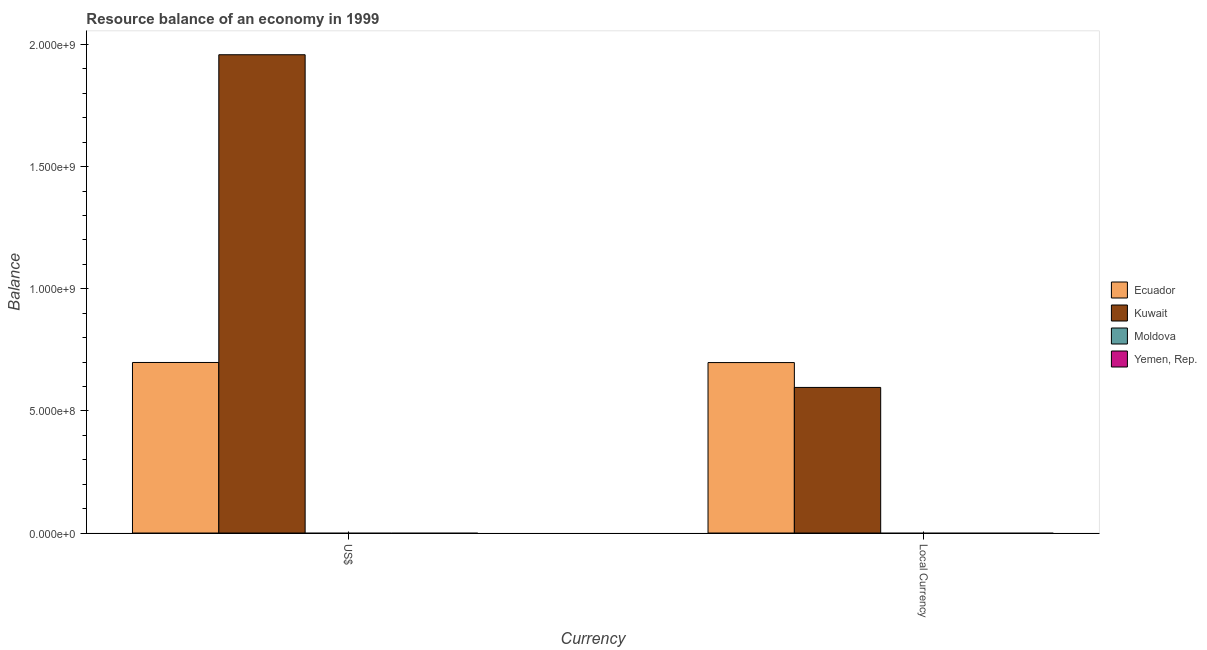Are the number of bars on each tick of the X-axis equal?
Provide a short and direct response. Yes. How many bars are there on the 1st tick from the right?
Offer a terse response. 2. What is the label of the 1st group of bars from the left?
Offer a terse response. US$. What is the resource balance in us$ in Ecuador?
Your answer should be very brief. 6.98e+08. Across all countries, what is the maximum resource balance in constant us$?
Keep it short and to the point. 6.98e+08. Across all countries, what is the minimum resource balance in us$?
Give a very brief answer. 0. In which country was the resource balance in us$ maximum?
Keep it short and to the point. Kuwait. What is the total resource balance in us$ in the graph?
Provide a short and direct response. 2.66e+09. What is the difference between the resource balance in us$ in Ecuador and that in Kuwait?
Offer a very short reply. -1.26e+09. What is the difference between the resource balance in constant us$ in Yemen, Rep. and the resource balance in us$ in Ecuador?
Your answer should be very brief. -6.98e+08. What is the average resource balance in constant us$ per country?
Provide a succinct answer. 3.23e+08. What is the difference between the resource balance in constant us$ and resource balance in us$ in Kuwait?
Your answer should be compact. -1.36e+09. In how many countries, is the resource balance in us$ greater than 800000000 units?
Make the answer very short. 1. What is the ratio of the resource balance in constant us$ in Ecuador to that in Kuwait?
Give a very brief answer. 1.17. In how many countries, is the resource balance in constant us$ greater than the average resource balance in constant us$ taken over all countries?
Offer a very short reply. 2. How many countries are there in the graph?
Make the answer very short. 4. Does the graph contain any zero values?
Your response must be concise. Yes. Does the graph contain grids?
Offer a terse response. No. Where does the legend appear in the graph?
Your answer should be very brief. Center right. How many legend labels are there?
Provide a short and direct response. 4. What is the title of the graph?
Your answer should be very brief. Resource balance of an economy in 1999. Does "Fiji" appear as one of the legend labels in the graph?
Your answer should be compact. No. What is the label or title of the X-axis?
Provide a short and direct response. Currency. What is the label or title of the Y-axis?
Offer a very short reply. Balance. What is the Balance in Ecuador in US$?
Offer a very short reply. 6.98e+08. What is the Balance of Kuwait in US$?
Your answer should be very brief. 1.96e+09. What is the Balance in Yemen, Rep. in US$?
Keep it short and to the point. 0. What is the Balance of Ecuador in Local Currency?
Ensure brevity in your answer.  6.98e+08. What is the Balance in Kuwait in Local Currency?
Provide a succinct answer. 5.96e+08. What is the Balance of Yemen, Rep. in Local Currency?
Provide a succinct answer. 0. Across all Currency, what is the maximum Balance in Ecuador?
Give a very brief answer. 6.98e+08. Across all Currency, what is the maximum Balance of Kuwait?
Ensure brevity in your answer.  1.96e+09. Across all Currency, what is the minimum Balance in Ecuador?
Your answer should be very brief. 6.98e+08. Across all Currency, what is the minimum Balance in Kuwait?
Your response must be concise. 5.96e+08. What is the total Balance in Ecuador in the graph?
Offer a terse response. 1.40e+09. What is the total Balance of Kuwait in the graph?
Provide a short and direct response. 2.55e+09. What is the difference between the Balance of Ecuador in US$ and that in Local Currency?
Make the answer very short. 3.49e+05. What is the difference between the Balance of Kuwait in US$ and that in Local Currency?
Keep it short and to the point. 1.36e+09. What is the difference between the Balance of Ecuador in US$ and the Balance of Kuwait in Local Currency?
Offer a terse response. 1.02e+08. What is the average Balance of Ecuador per Currency?
Your response must be concise. 6.98e+08. What is the average Balance in Kuwait per Currency?
Your response must be concise. 1.28e+09. What is the difference between the Balance of Ecuador and Balance of Kuwait in US$?
Your answer should be very brief. -1.26e+09. What is the difference between the Balance in Ecuador and Balance in Kuwait in Local Currency?
Give a very brief answer. 1.02e+08. What is the ratio of the Balance of Ecuador in US$ to that in Local Currency?
Keep it short and to the point. 1. What is the ratio of the Balance of Kuwait in US$ to that in Local Currency?
Provide a succinct answer. 3.29. What is the difference between the highest and the second highest Balance of Ecuador?
Your answer should be very brief. 3.49e+05. What is the difference between the highest and the second highest Balance of Kuwait?
Provide a short and direct response. 1.36e+09. What is the difference between the highest and the lowest Balance in Ecuador?
Offer a very short reply. 3.49e+05. What is the difference between the highest and the lowest Balance of Kuwait?
Your response must be concise. 1.36e+09. 